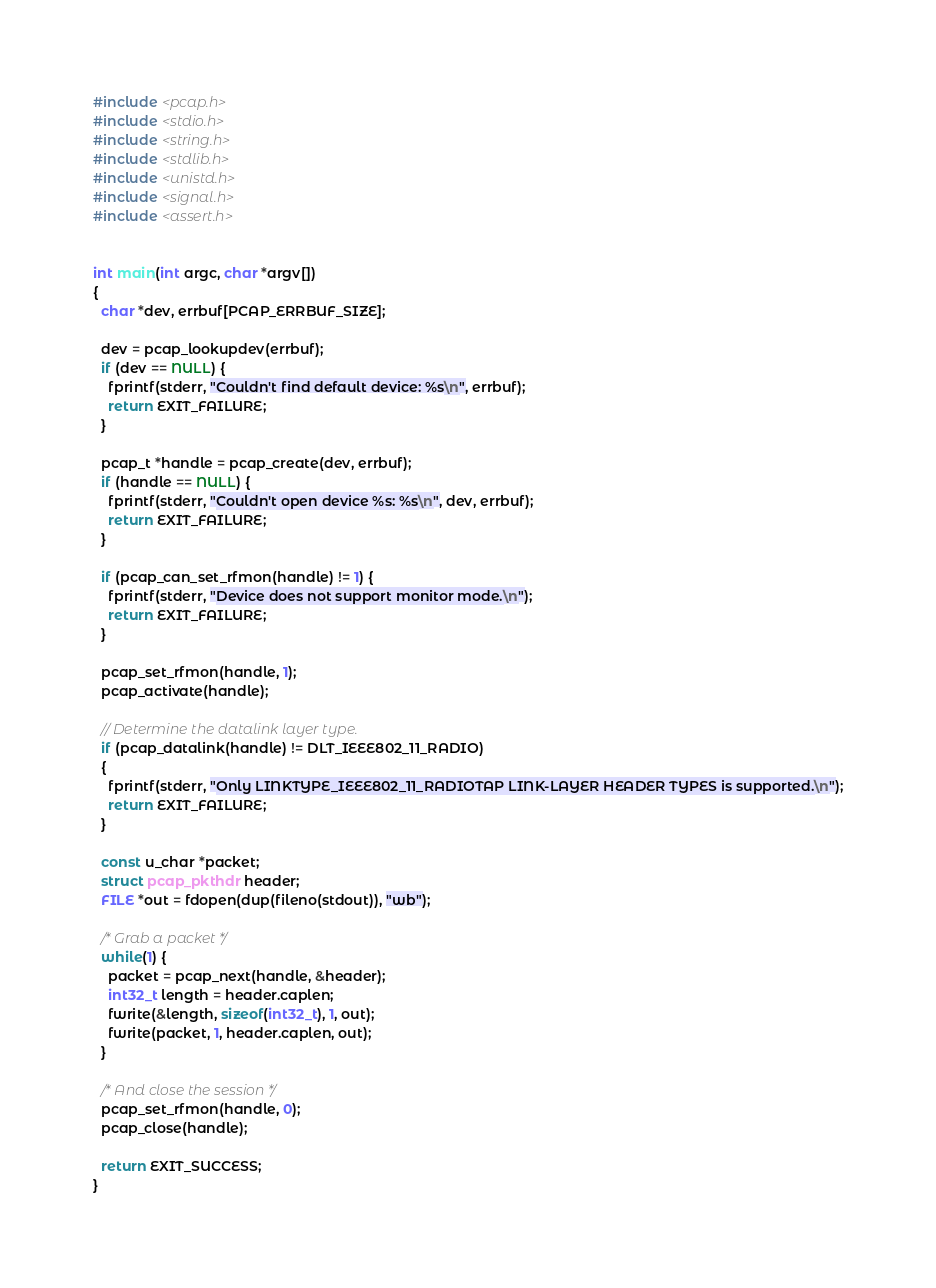<code> <loc_0><loc_0><loc_500><loc_500><_C_>#include <pcap.h>
#include <stdio.h>
#include <string.h>
#include <stdlib.h>
#include <unistd.h>
#include <signal.h>
#include <assert.h>


int main(int argc, char *argv[])
{
  char *dev, errbuf[PCAP_ERRBUF_SIZE];

  dev = pcap_lookupdev(errbuf);
  if (dev == NULL) {
    fprintf(stderr, "Couldn't find default device: %s\n", errbuf);
    return EXIT_FAILURE;
  }

  pcap_t *handle = pcap_create(dev, errbuf);
  if (handle == NULL) {
    fprintf(stderr, "Couldn't open device %s: %s\n", dev, errbuf);
    return EXIT_FAILURE;
  }

  if (pcap_can_set_rfmon(handle) != 1) {
    fprintf(stderr, "Device does not support monitor mode.\n");
    return EXIT_FAILURE;
  }

  pcap_set_rfmon(handle, 1);
  pcap_activate(handle);

  // Determine the datalink layer type.
  if (pcap_datalink(handle) != DLT_IEEE802_11_RADIO)
  {
    fprintf(stderr, "Only LINKTYPE_IEEE802_11_RADIOTAP LINK-LAYER HEADER TYPES is supported.\n");
    return EXIT_FAILURE;
  }

  const u_char *packet;
  struct pcap_pkthdr header;
  FILE *out = fdopen(dup(fileno(stdout)), "wb");

  /* Grab a packet */
  while(1) {
    packet = pcap_next(handle, &header);
    int32_t length = header.caplen;
    fwrite(&length, sizeof(int32_t), 1, out);
    fwrite(packet, 1, header.caplen, out);
  }

  /* And close the session */
  pcap_set_rfmon(handle, 0);
  pcap_close(handle);

  return EXIT_SUCCESS;
}
</code> 